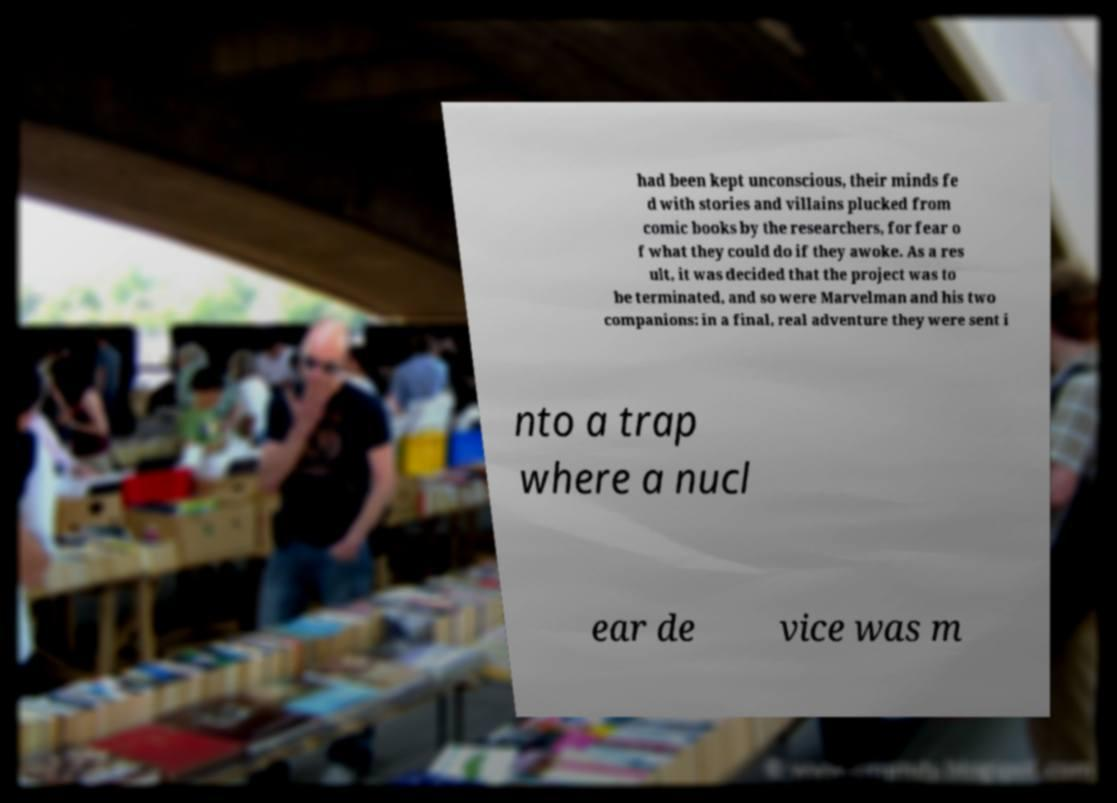Can you read and provide the text displayed in the image?This photo seems to have some interesting text. Can you extract and type it out for me? had been kept unconscious, their minds fe d with stories and villains plucked from comic books by the researchers, for fear o f what they could do if they awoke. As a res ult, it was decided that the project was to be terminated, and so were Marvelman and his two companions: in a final, real adventure they were sent i nto a trap where a nucl ear de vice was m 